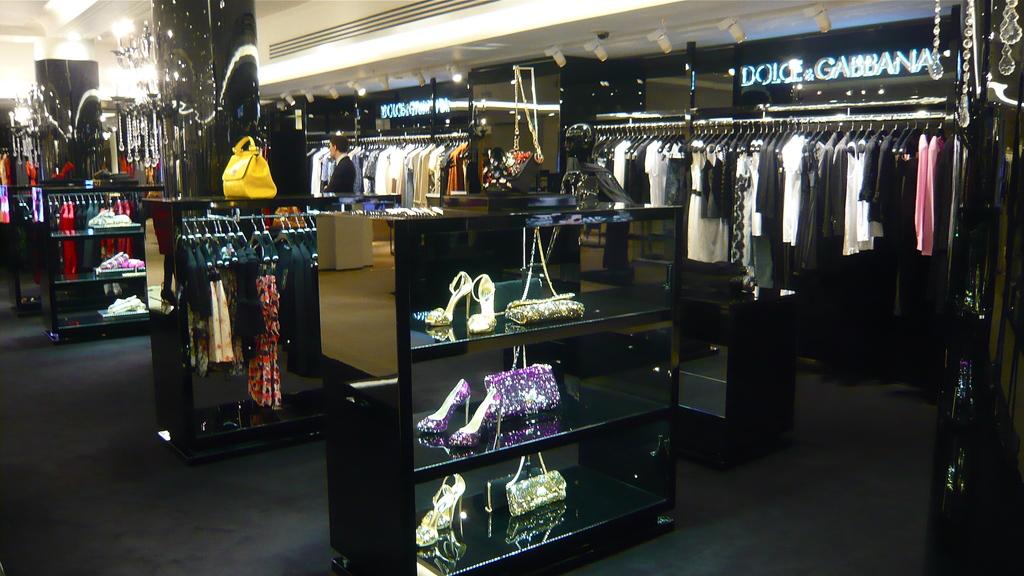What store is this?
Offer a very short reply. Dolce & gabbana. How many letters are in the first part of the name on the sign?
Ensure brevity in your answer.  5. 